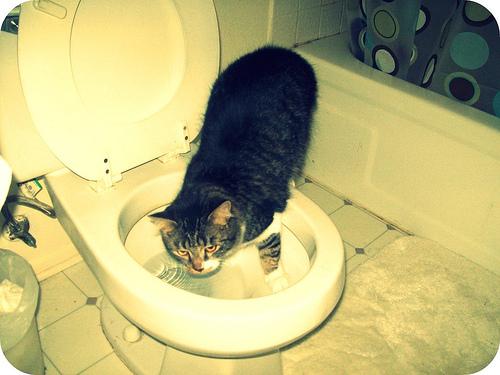Is the cat thirsty?
Write a very short answer. Yes. How many paws does the cat have in the toilet?
Quick response, please. 2. Is the cat the most vivid item in this photo?
Write a very short answer. Yes. 